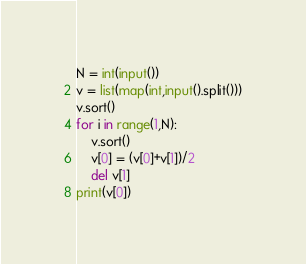Convert code to text. <code><loc_0><loc_0><loc_500><loc_500><_Python_>N = int(input())
v = list(map(int,input().split()))
v.sort()
for i in range(1,N):
    v.sort()
    v[0] = (v[0]+v[1])/2
    del v[1]
print(v[0])</code> 